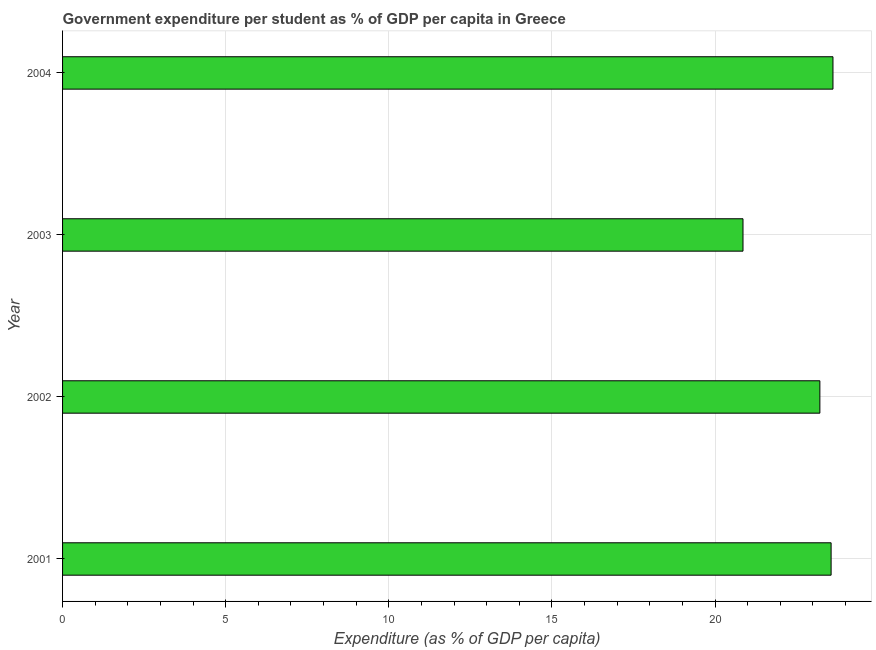What is the title of the graph?
Provide a succinct answer. Government expenditure per student as % of GDP per capita in Greece. What is the label or title of the X-axis?
Provide a short and direct response. Expenditure (as % of GDP per capita). What is the government expenditure per student in 2002?
Ensure brevity in your answer.  23.21. Across all years, what is the maximum government expenditure per student?
Keep it short and to the point. 23.61. Across all years, what is the minimum government expenditure per student?
Your answer should be very brief. 20.86. In which year was the government expenditure per student maximum?
Give a very brief answer. 2004. What is the sum of the government expenditure per student?
Your response must be concise. 91.24. What is the difference between the government expenditure per student in 2003 and 2004?
Your response must be concise. -2.76. What is the average government expenditure per student per year?
Offer a terse response. 22.81. What is the median government expenditure per student?
Offer a terse response. 23.38. In how many years, is the government expenditure per student greater than 1 %?
Provide a short and direct response. 4. What is the ratio of the government expenditure per student in 2002 to that in 2003?
Your answer should be very brief. 1.11. Is the difference between the government expenditure per student in 2003 and 2004 greater than the difference between any two years?
Your answer should be compact. Yes. What is the difference between the highest and the second highest government expenditure per student?
Your response must be concise. 0.06. Is the sum of the government expenditure per student in 2001 and 2003 greater than the maximum government expenditure per student across all years?
Your response must be concise. Yes. What is the difference between the highest and the lowest government expenditure per student?
Keep it short and to the point. 2.76. How many years are there in the graph?
Make the answer very short. 4. What is the difference between two consecutive major ticks on the X-axis?
Offer a terse response. 5. What is the Expenditure (as % of GDP per capita) of 2001?
Your response must be concise. 23.56. What is the Expenditure (as % of GDP per capita) in 2002?
Offer a very short reply. 23.21. What is the Expenditure (as % of GDP per capita) in 2003?
Ensure brevity in your answer.  20.86. What is the Expenditure (as % of GDP per capita) in 2004?
Make the answer very short. 23.61. What is the difference between the Expenditure (as % of GDP per capita) in 2001 and 2002?
Give a very brief answer. 0.34. What is the difference between the Expenditure (as % of GDP per capita) in 2001 and 2003?
Provide a succinct answer. 2.7. What is the difference between the Expenditure (as % of GDP per capita) in 2001 and 2004?
Give a very brief answer. -0.06. What is the difference between the Expenditure (as % of GDP per capita) in 2002 and 2003?
Your answer should be very brief. 2.36. What is the difference between the Expenditure (as % of GDP per capita) in 2002 and 2004?
Provide a short and direct response. -0.4. What is the difference between the Expenditure (as % of GDP per capita) in 2003 and 2004?
Give a very brief answer. -2.76. What is the ratio of the Expenditure (as % of GDP per capita) in 2001 to that in 2003?
Offer a terse response. 1.13. What is the ratio of the Expenditure (as % of GDP per capita) in 2001 to that in 2004?
Give a very brief answer. 1. What is the ratio of the Expenditure (as % of GDP per capita) in 2002 to that in 2003?
Offer a very short reply. 1.11. What is the ratio of the Expenditure (as % of GDP per capita) in 2002 to that in 2004?
Ensure brevity in your answer.  0.98. What is the ratio of the Expenditure (as % of GDP per capita) in 2003 to that in 2004?
Offer a very short reply. 0.88. 